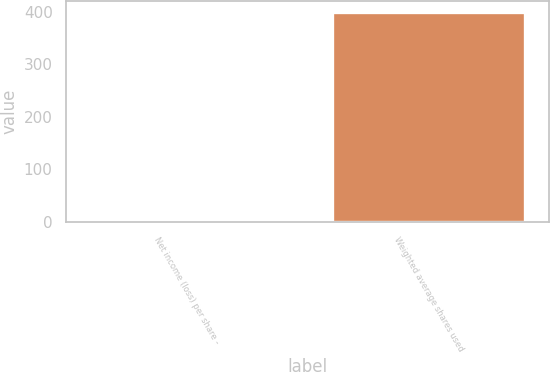Convert chart. <chart><loc_0><loc_0><loc_500><loc_500><bar_chart><fcel>Net income (loss) per share -<fcel>Weighted average shares used<nl><fcel>1.91<fcel>399.91<nl></chart> 